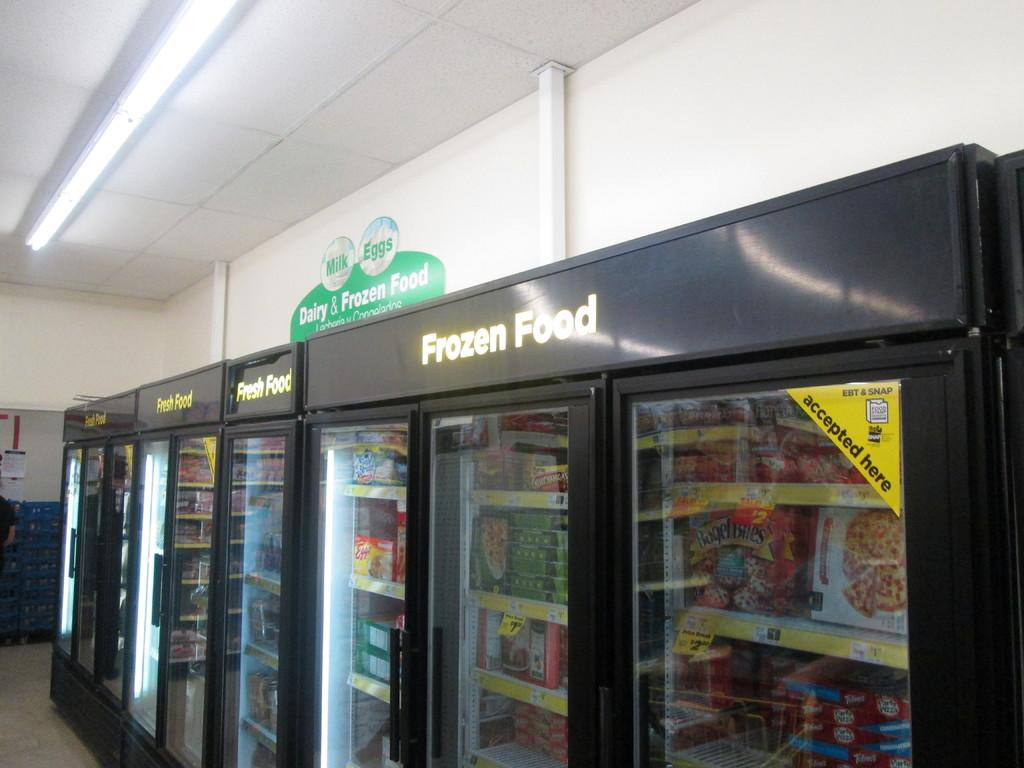<image>
Present a compact description of the photo's key features. a store interior with fridges for FROZEN Food and other items 